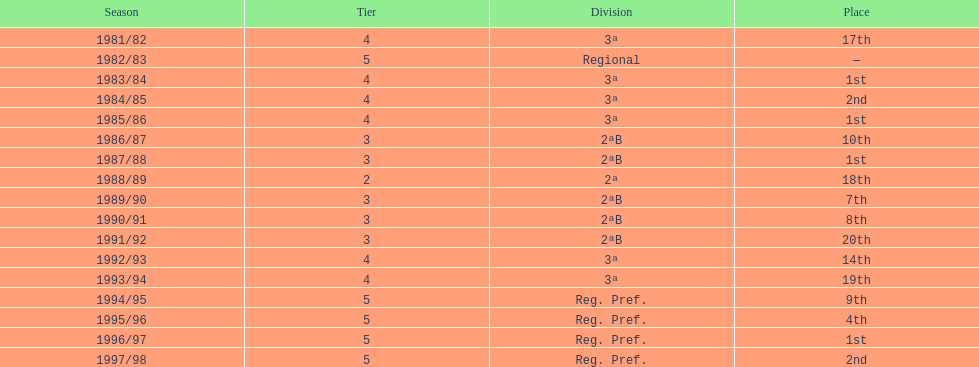In what years did the team finish 17th or worse? 1981/82, 1988/89, 1991/92, 1993/94. Of those, in which year the team finish worse? 1991/92. 